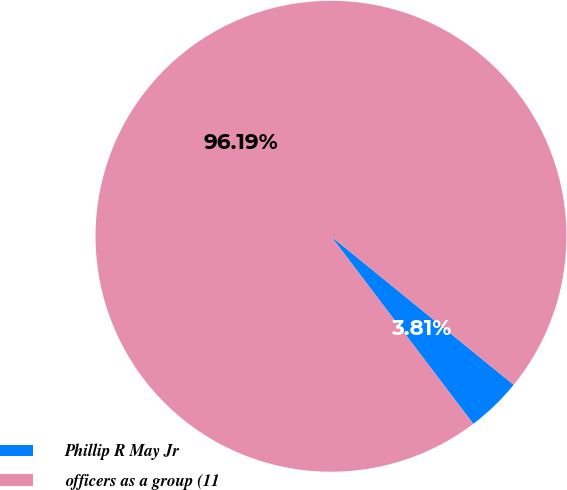Convert chart. <chart><loc_0><loc_0><loc_500><loc_500><pie_chart><fcel>Phillip R May Jr<fcel>officers as a group (11<nl><fcel>3.81%<fcel>96.19%<nl></chart> 